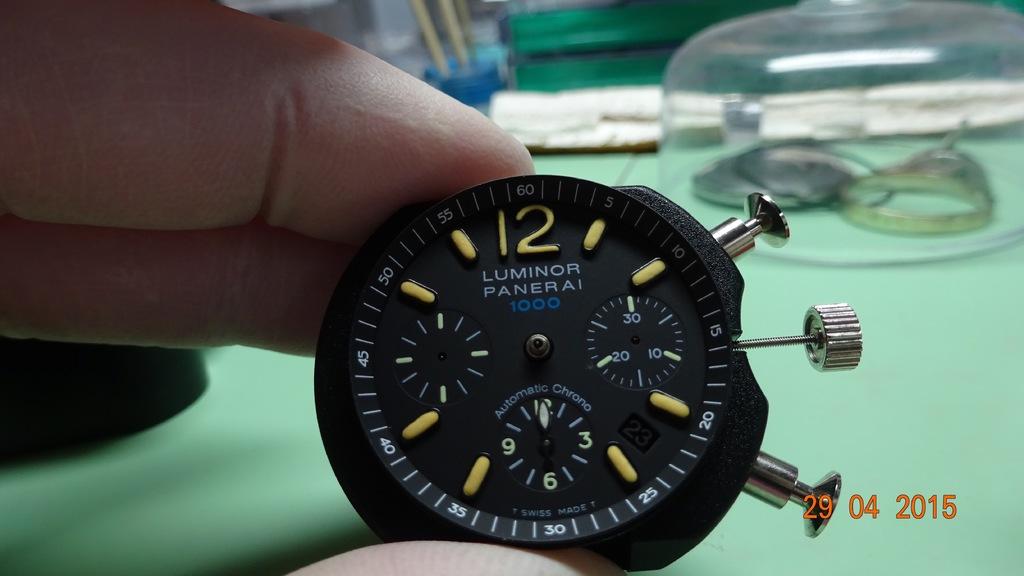What type of watch is that?
Provide a short and direct response. Luminor panerai. What brand of watch?
Give a very brief answer. Luminor panerai. 